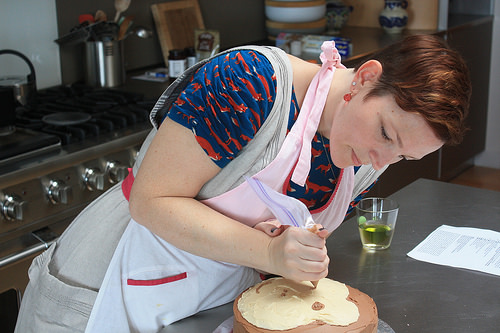<image>
Can you confirm if the utensil holder is on the stove? Yes. Looking at the image, I can see the utensil holder is positioned on top of the stove, with the stove providing support. 